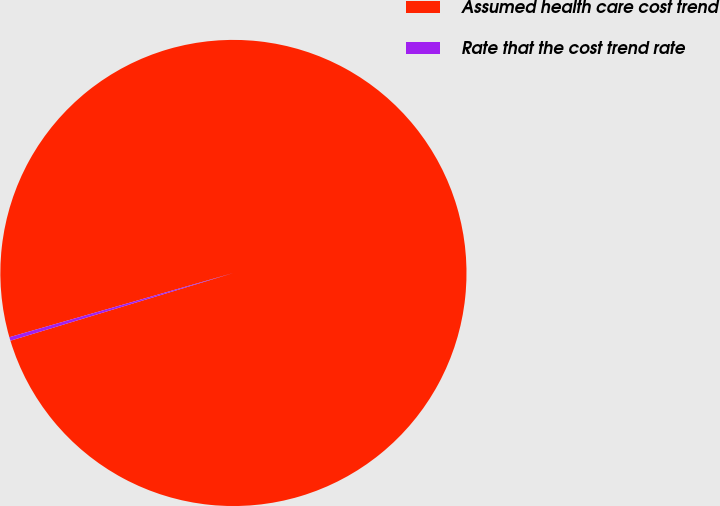Convert chart to OTSL. <chart><loc_0><loc_0><loc_500><loc_500><pie_chart><fcel>Assumed health care cost trend<fcel>Rate that the cost trend rate<nl><fcel>99.75%<fcel>0.25%<nl></chart> 